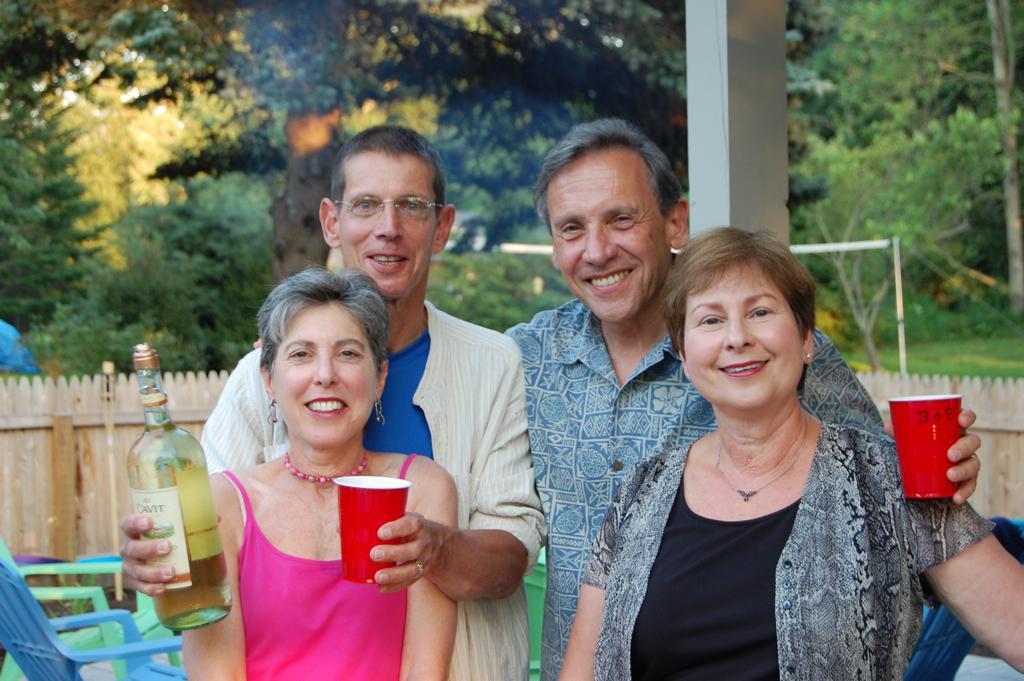Could you give a brief overview of what you see in this image? This picture is clicked outside. In the foreground we can see the two women wearing t-shirts, smiling and standing, behind them we can see the two men holding some objects, smiling and standing. In the background we can see the trees, plants, green grass, pillar, wooden fence and some chairs. 